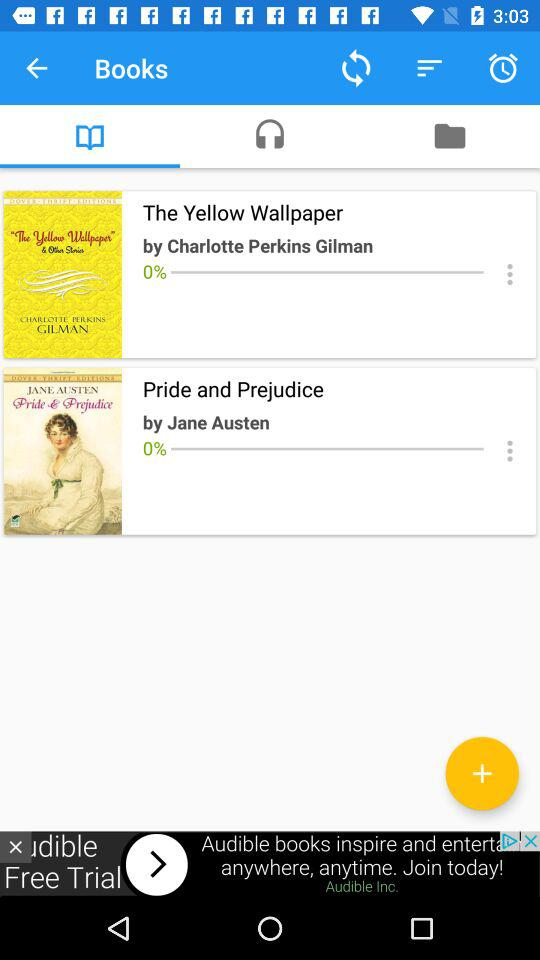Which tab is selected? The selected tab is "Books". 